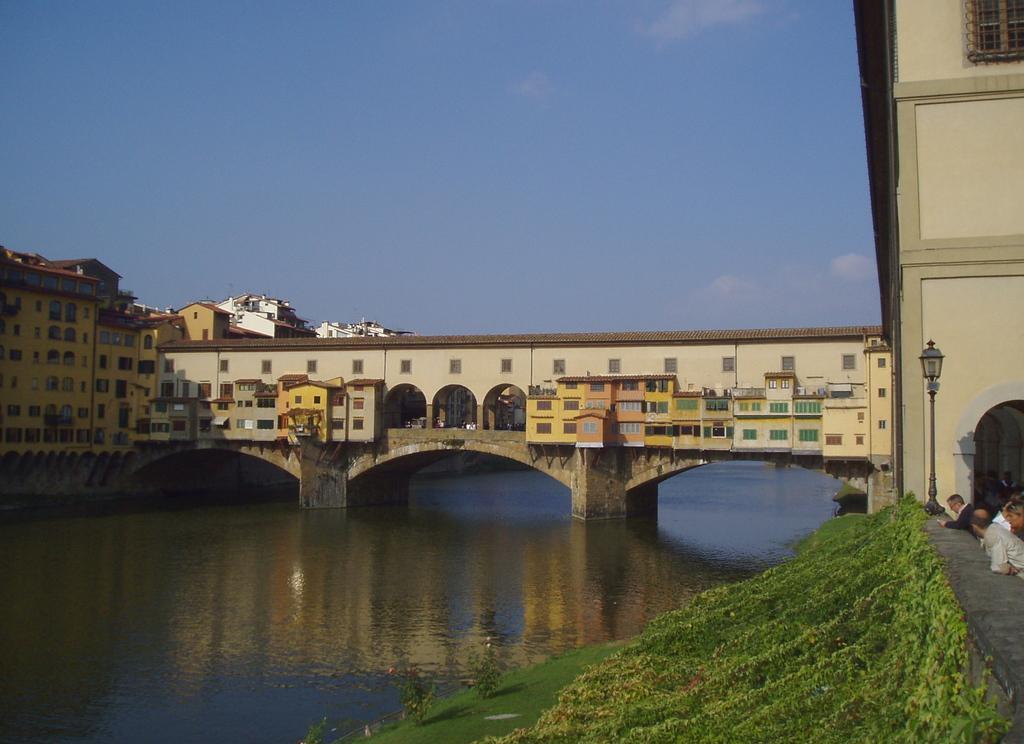Please provide a concise description of this image. In this picture I can see there is a lake and there is a bridge on the lake and there are buildings constructed on the bridge and there are plants and grass on to right side. There are few people standing and the sky is clear. 